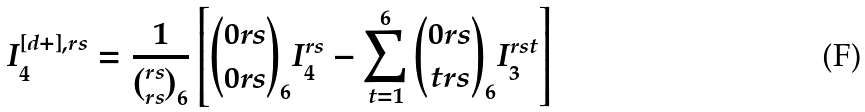Convert formula to latex. <formula><loc_0><loc_0><loc_500><loc_500>I _ { 4 } ^ { [ d + ] , r s } = \frac { 1 } { { r s \choose r s } _ { 6 } } \left [ { { 0 r s \choose 0 r s } _ { 6 } } I _ { 4 } ^ { r s } - \sum ^ { 6 } _ { t = 1 } { { 0 r s \choose t r s } _ { 6 } } I _ { 3 } ^ { r s t } \right ]</formula> 